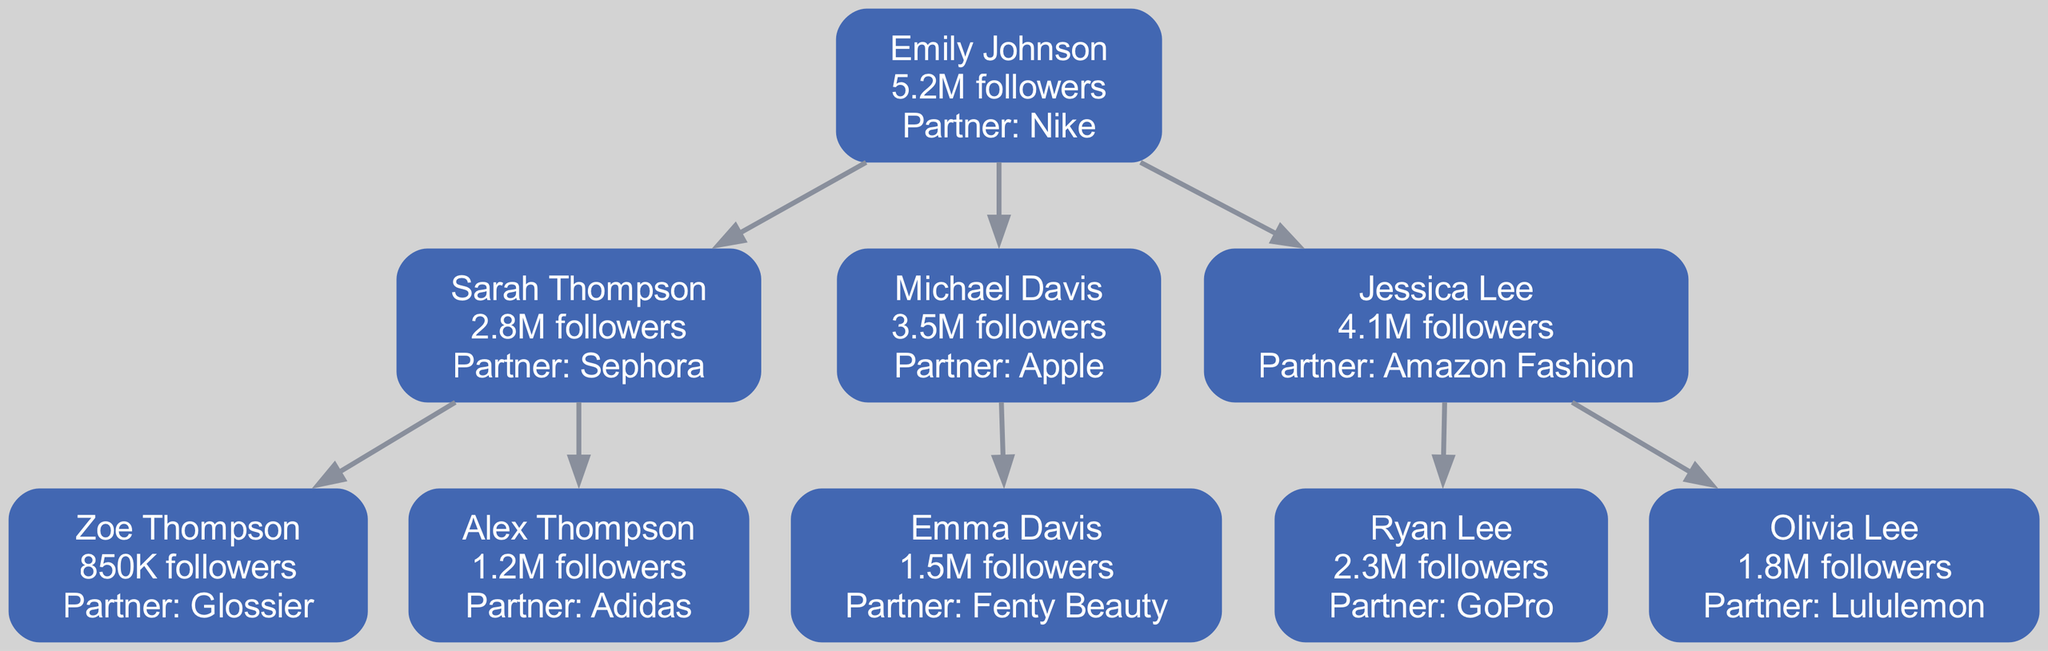What's the highest follower count among the influencers? The diagram shows multiple influencers with different follower counts. The highest follower count is attributed to Emily Johnson, who has 5.2 million followers.
Answer: 5.2M Who is Sarah Thompson's brand partner? Looking at Sarah Thompson's section in the diagram, her partnership is with Sephora.
Answer: Sephora How many children does Michael Davis have? In the diagram, Michael Davis has one child listed, Emma Davis. Counting the children under Michael, we find one child.
Answer: 1 What is the follower count of Zoe Thompson? By examining Zoe Thompson's node in the diagram, we see that she has 850K followers listed next to her name.
Answer: 850K Which influencer has a partnership with Nike? The diagram indicates that Emily Johnson has a partnership with Nike, denoted in her node information.
Answer: Emily Johnson What is the total number of influencers in the family tree? The influencers can be counted from the root and all children in the diagram. There are five influencers in total: Emily, Sarah, Michael, Jessica, and their respective children.
Answer: 5 Which influencer has the most brand partnerships mentioned? Upon reviewing the diagram, all influencers show only one mentioned partnership each. Thus, there is no influencer with multiple partnerships mentioned.
Answer: None Is Ryan Lee a child of Jessica Lee? The diagram depicts Ryan Lee as a child of Jessica Lee. They are connected hierarchically in the family tree format, confirming this relationship.
Answer: Yes Which influencer is closest, in terms of follower count, to 1 million? The follower counts of each influencer are compared, and Alex Thompson has 1.2 million followers, making him the closest to 1 million in the diagram.
Answer: Alex Thompson 